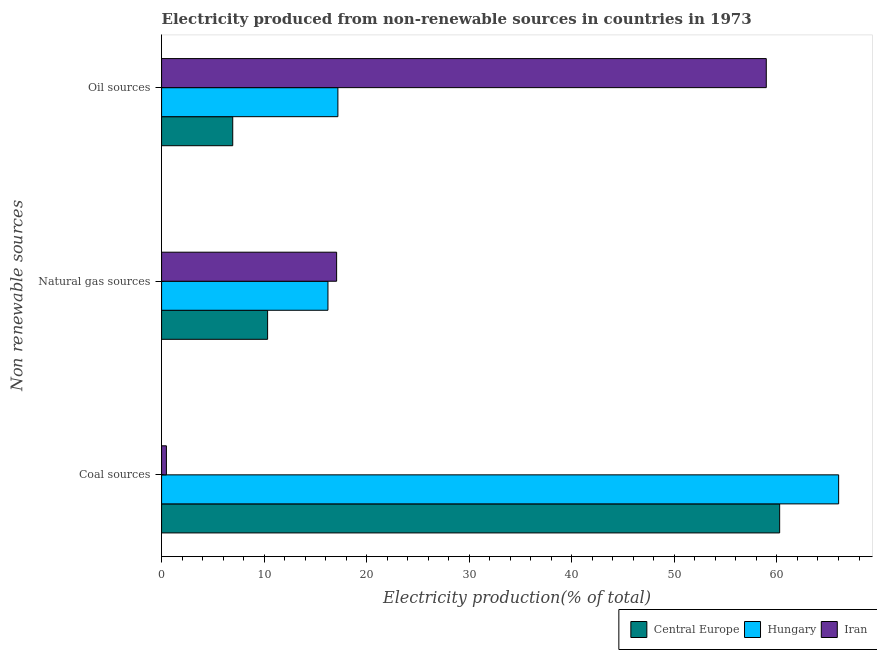How many different coloured bars are there?
Keep it short and to the point. 3. How many groups of bars are there?
Provide a short and direct response. 3. Are the number of bars on each tick of the Y-axis equal?
Offer a very short reply. Yes. What is the label of the 1st group of bars from the top?
Your answer should be compact. Oil sources. What is the percentage of electricity produced by coal in Iran?
Offer a terse response. 0.47. Across all countries, what is the maximum percentage of electricity produced by natural gas?
Make the answer very short. 17.07. Across all countries, what is the minimum percentage of electricity produced by coal?
Your answer should be compact. 0.47. In which country was the percentage of electricity produced by natural gas maximum?
Make the answer very short. Iran. In which country was the percentage of electricity produced by oil sources minimum?
Your response must be concise. Central Europe. What is the total percentage of electricity produced by coal in the graph?
Offer a terse response. 126.75. What is the difference between the percentage of electricity produced by oil sources in Iran and that in Hungary?
Your answer should be very brief. 41.77. What is the difference between the percentage of electricity produced by oil sources in Central Europe and the percentage of electricity produced by coal in Hungary?
Your response must be concise. -59.08. What is the average percentage of electricity produced by coal per country?
Your answer should be very brief. 42.25. What is the difference between the percentage of electricity produced by coal and percentage of electricity produced by oil sources in Central Europe?
Keep it short and to the point. 53.33. In how many countries, is the percentage of electricity produced by oil sources greater than 44 %?
Offer a terse response. 1. What is the ratio of the percentage of electricity produced by oil sources in Central Europe to that in Iran?
Your response must be concise. 0.12. What is the difference between the highest and the second highest percentage of electricity produced by natural gas?
Your answer should be compact. 0.85. What is the difference between the highest and the lowest percentage of electricity produced by coal?
Your answer should be very brief. 65.54. In how many countries, is the percentage of electricity produced by natural gas greater than the average percentage of electricity produced by natural gas taken over all countries?
Ensure brevity in your answer.  2. What does the 1st bar from the top in Coal sources represents?
Your answer should be very brief. Iran. What does the 3rd bar from the bottom in Oil sources represents?
Ensure brevity in your answer.  Iran. Is it the case that in every country, the sum of the percentage of electricity produced by coal and percentage of electricity produced by natural gas is greater than the percentage of electricity produced by oil sources?
Your answer should be compact. No. How many countries are there in the graph?
Offer a terse response. 3. Does the graph contain any zero values?
Keep it short and to the point. No. Where does the legend appear in the graph?
Your answer should be compact. Bottom right. How many legend labels are there?
Your answer should be very brief. 3. What is the title of the graph?
Offer a very short reply. Electricity produced from non-renewable sources in countries in 1973. What is the label or title of the X-axis?
Provide a short and direct response. Electricity production(% of total). What is the label or title of the Y-axis?
Keep it short and to the point. Non renewable sources. What is the Electricity production(% of total) of Central Europe in Coal sources?
Ensure brevity in your answer.  60.26. What is the Electricity production(% of total) in Hungary in Coal sources?
Give a very brief answer. 66.01. What is the Electricity production(% of total) in Iran in Coal sources?
Keep it short and to the point. 0.47. What is the Electricity production(% of total) of Central Europe in Natural gas sources?
Keep it short and to the point. 10.34. What is the Electricity production(% of total) in Hungary in Natural gas sources?
Your answer should be very brief. 16.22. What is the Electricity production(% of total) in Iran in Natural gas sources?
Your answer should be compact. 17.07. What is the Electricity production(% of total) of Central Europe in Oil sources?
Offer a very short reply. 6.94. What is the Electricity production(% of total) of Hungary in Oil sources?
Keep it short and to the point. 17.19. What is the Electricity production(% of total) of Iran in Oil sources?
Make the answer very short. 58.96. Across all Non renewable sources, what is the maximum Electricity production(% of total) in Central Europe?
Provide a short and direct response. 60.26. Across all Non renewable sources, what is the maximum Electricity production(% of total) of Hungary?
Keep it short and to the point. 66.01. Across all Non renewable sources, what is the maximum Electricity production(% of total) of Iran?
Your answer should be very brief. 58.96. Across all Non renewable sources, what is the minimum Electricity production(% of total) in Central Europe?
Your answer should be very brief. 6.94. Across all Non renewable sources, what is the minimum Electricity production(% of total) of Hungary?
Give a very brief answer. 16.22. Across all Non renewable sources, what is the minimum Electricity production(% of total) in Iran?
Offer a very short reply. 0.47. What is the total Electricity production(% of total) of Central Europe in the graph?
Offer a terse response. 77.54. What is the total Electricity production(% of total) in Hungary in the graph?
Keep it short and to the point. 99.43. What is the total Electricity production(% of total) of Iran in the graph?
Provide a short and direct response. 76.5. What is the difference between the Electricity production(% of total) in Central Europe in Coal sources and that in Natural gas sources?
Provide a short and direct response. 49.92. What is the difference between the Electricity production(% of total) in Hungary in Coal sources and that in Natural gas sources?
Your answer should be very brief. 49.79. What is the difference between the Electricity production(% of total) in Iran in Coal sources and that in Natural gas sources?
Ensure brevity in your answer.  -16.6. What is the difference between the Electricity production(% of total) in Central Europe in Coal sources and that in Oil sources?
Your answer should be very brief. 53.33. What is the difference between the Electricity production(% of total) of Hungary in Coal sources and that in Oil sources?
Offer a very short reply. 48.82. What is the difference between the Electricity production(% of total) of Iran in Coal sources and that in Oil sources?
Make the answer very short. -58.49. What is the difference between the Electricity production(% of total) in Central Europe in Natural gas sources and that in Oil sources?
Ensure brevity in your answer.  3.4. What is the difference between the Electricity production(% of total) of Hungary in Natural gas sources and that in Oil sources?
Your response must be concise. -0.97. What is the difference between the Electricity production(% of total) of Iran in Natural gas sources and that in Oil sources?
Keep it short and to the point. -41.89. What is the difference between the Electricity production(% of total) in Central Europe in Coal sources and the Electricity production(% of total) in Hungary in Natural gas sources?
Provide a short and direct response. 44.04. What is the difference between the Electricity production(% of total) in Central Europe in Coal sources and the Electricity production(% of total) in Iran in Natural gas sources?
Ensure brevity in your answer.  43.2. What is the difference between the Electricity production(% of total) of Hungary in Coal sources and the Electricity production(% of total) of Iran in Natural gas sources?
Provide a succinct answer. 48.95. What is the difference between the Electricity production(% of total) in Central Europe in Coal sources and the Electricity production(% of total) in Hungary in Oil sources?
Make the answer very short. 43.07. What is the difference between the Electricity production(% of total) in Central Europe in Coal sources and the Electricity production(% of total) in Iran in Oil sources?
Make the answer very short. 1.3. What is the difference between the Electricity production(% of total) in Hungary in Coal sources and the Electricity production(% of total) in Iran in Oil sources?
Offer a terse response. 7.06. What is the difference between the Electricity production(% of total) in Central Europe in Natural gas sources and the Electricity production(% of total) in Hungary in Oil sources?
Make the answer very short. -6.85. What is the difference between the Electricity production(% of total) of Central Europe in Natural gas sources and the Electricity production(% of total) of Iran in Oil sources?
Give a very brief answer. -48.62. What is the difference between the Electricity production(% of total) in Hungary in Natural gas sources and the Electricity production(% of total) in Iran in Oil sources?
Your answer should be very brief. -42.74. What is the average Electricity production(% of total) of Central Europe per Non renewable sources?
Keep it short and to the point. 25.85. What is the average Electricity production(% of total) in Hungary per Non renewable sources?
Provide a succinct answer. 33.14. What is the average Electricity production(% of total) in Iran per Non renewable sources?
Provide a short and direct response. 25.5. What is the difference between the Electricity production(% of total) of Central Europe and Electricity production(% of total) of Hungary in Coal sources?
Make the answer very short. -5.75. What is the difference between the Electricity production(% of total) in Central Europe and Electricity production(% of total) in Iran in Coal sources?
Provide a succinct answer. 59.79. What is the difference between the Electricity production(% of total) of Hungary and Electricity production(% of total) of Iran in Coal sources?
Your response must be concise. 65.54. What is the difference between the Electricity production(% of total) of Central Europe and Electricity production(% of total) of Hungary in Natural gas sources?
Provide a short and direct response. -5.88. What is the difference between the Electricity production(% of total) in Central Europe and Electricity production(% of total) in Iran in Natural gas sources?
Give a very brief answer. -6.73. What is the difference between the Electricity production(% of total) in Hungary and Electricity production(% of total) in Iran in Natural gas sources?
Give a very brief answer. -0.85. What is the difference between the Electricity production(% of total) in Central Europe and Electricity production(% of total) in Hungary in Oil sources?
Keep it short and to the point. -10.25. What is the difference between the Electricity production(% of total) in Central Europe and Electricity production(% of total) in Iran in Oil sources?
Offer a terse response. -52.02. What is the difference between the Electricity production(% of total) in Hungary and Electricity production(% of total) in Iran in Oil sources?
Provide a succinct answer. -41.77. What is the ratio of the Electricity production(% of total) of Central Europe in Coal sources to that in Natural gas sources?
Keep it short and to the point. 5.83. What is the ratio of the Electricity production(% of total) in Hungary in Coal sources to that in Natural gas sources?
Provide a short and direct response. 4.07. What is the ratio of the Electricity production(% of total) in Iran in Coal sources to that in Natural gas sources?
Keep it short and to the point. 0.03. What is the ratio of the Electricity production(% of total) of Central Europe in Coal sources to that in Oil sources?
Your answer should be very brief. 8.69. What is the ratio of the Electricity production(% of total) of Hungary in Coal sources to that in Oil sources?
Make the answer very short. 3.84. What is the ratio of the Electricity production(% of total) in Iran in Coal sources to that in Oil sources?
Offer a very short reply. 0.01. What is the ratio of the Electricity production(% of total) in Central Europe in Natural gas sources to that in Oil sources?
Your answer should be very brief. 1.49. What is the ratio of the Electricity production(% of total) in Hungary in Natural gas sources to that in Oil sources?
Provide a short and direct response. 0.94. What is the ratio of the Electricity production(% of total) of Iran in Natural gas sources to that in Oil sources?
Give a very brief answer. 0.29. What is the difference between the highest and the second highest Electricity production(% of total) in Central Europe?
Ensure brevity in your answer.  49.92. What is the difference between the highest and the second highest Electricity production(% of total) of Hungary?
Give a very brief answer. 48.82. What is the difference between the highest and the second highest Electricity production(% of total) in Iran?
Make the answer very short. 41.89. What is the difference between the highest and the lowest Electricity production(% of total) of Central Europe?
Your response must be concise. 53.33. What is the difference between the highest and the lowest Electricity production(% of total) of Hungary?
Your response must be concise. 49.79. What is the difference between the highest and the lowest Electricity production(% of total) of Iran?
Keep it short and to the point. 58.49. 